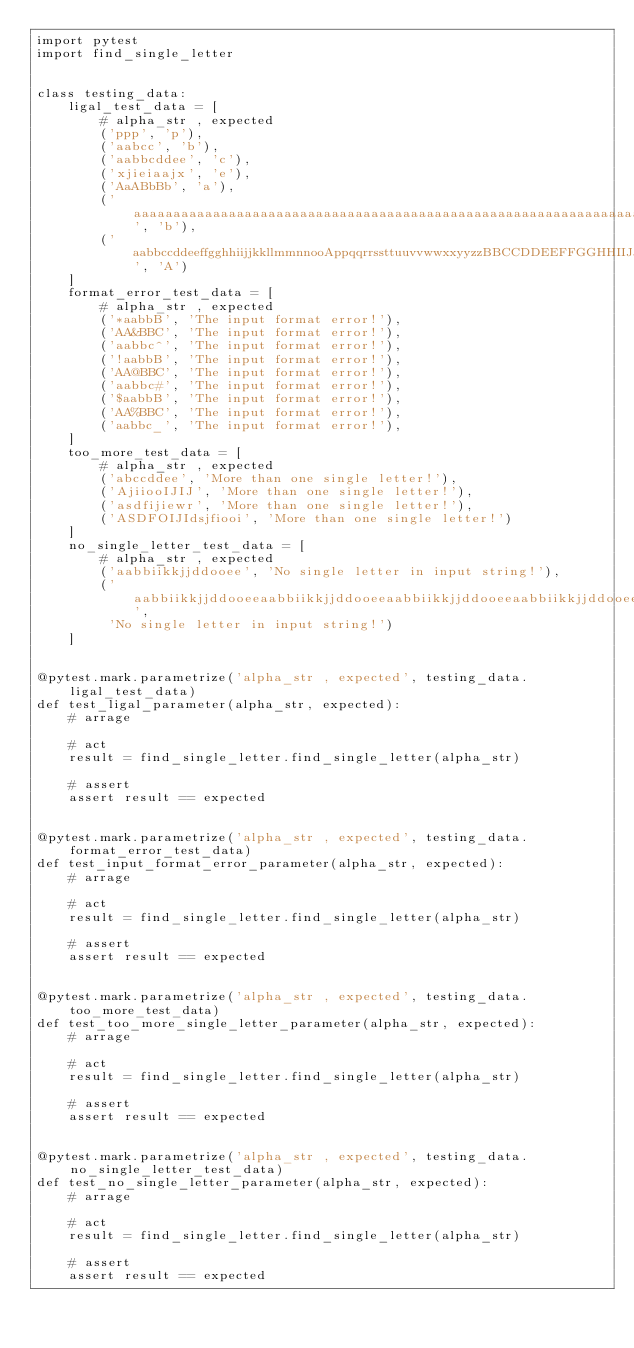<code> <loc_0><loc_0><loc_500><loc_500><_Python_>import pytest
import find_single_letter


class testing_data:
    ligal_test_data = [
        # alpha_str , expected
        ('ppp', 'p'),
        ('aabcc', 'b'),
        ('aabbcddee', 'c'),
        ('xjieiaajx', 'e'),
        ('AaABbBb', 'a'),
        ('aaaaaaaaaaaaaaaaaaaaaaaaaaaaaaaaaaaaaaaaaaaaaaaaaaaaaaaaaaaaaaaaaaaaaaaaaaaaaaaaaaaaaaaaaaaaaaaaaab', 'b'),
        ('aabbccddeeffgghhiijjkkllmmnnooAppqqrrssttuuvvwwxxyyzzBBCCDDEEFFGGHHIIJJKKLLMMOOPPQQRRSSTTUUVVWWXXYY', 'A')
    ]
    format_error_test_data = [
        # alpha_str , expected
        ('*aabbB', 'The input format error!'),
        ('AA&BBC', 'The input format error!'),
        ('aabbc^', 'The input format error!'),
        ('!aabbB', 'The input format error!'),
        ('AA@BBC', 'The input format error!'),
        ('aabbc#', 'The input format error!'),
        ('$aabbB', 'The input format error!'),
        ('AA%BBC', 'The input format error!'),
        ('aabbc_', 'The input format error!'),
    ]
    too_more_test_data = [
        # alpha_str , expected
        ('abccddee', 'More than one single letter!'),
        ('AjiiooIJIJ', 'More than one single letter!'),
        ('asdfijiewr', 'More than one single letter!'),
        ('ASDFOIJIdsjfiooi', 'More than one single letter!')
    ]
    no_single_letter_test_data = [
        # alpha_str , expected
        ('aabbiikkjjddooee', 'No single letter in input string!'),
        ('aabbiikkjjddooeeaabbiikkjjddooeeaabbiikkjjddooeeaabbiikkjjddooeebbiikkjjddooeeaabbiikkjjddooeeUUII',
         'No single letter in input string!')
    ]


@pytest.mark.parametrize('alpha_str , expected', testing_data.ligal_test_data)
def test_ligal_parameter(alpha_str, expected):
    # arrage

    # act
    result = find_single_letter.find_single_letter(alpha_str)

    # assert
    assert result == expected


@pytest.mark.parametrize('alpha_str , expected', testing_data.format_error_test_data)
def test_input_format_error_parameter(alpha_str, expected):
    # arrage

    # act
    result = find_single_letter.find_single_letter(alpha_str)

    # assert
    assert result == expected


@pytest.mark.parametrize('alpha_str , expected', testing_data.too_more_test_data)
def test_too_more_single_letter_parameter(alpha_str, expected):
    # arrage

    # act
    result = find_single_letter.find_single_letter(alpha_str)

    # assert
    assert result == expected


@pytest.mark.parametrize('alpha_str , expected', testing_data.no_single_letter_test_data)
def test_no_single_letter_parameter(alpha_str, expected):
    # arrage

    # act
    result = find_single_letter.find_single_letter(alpha_str)

    # assert
    assert result == expected
</code> 